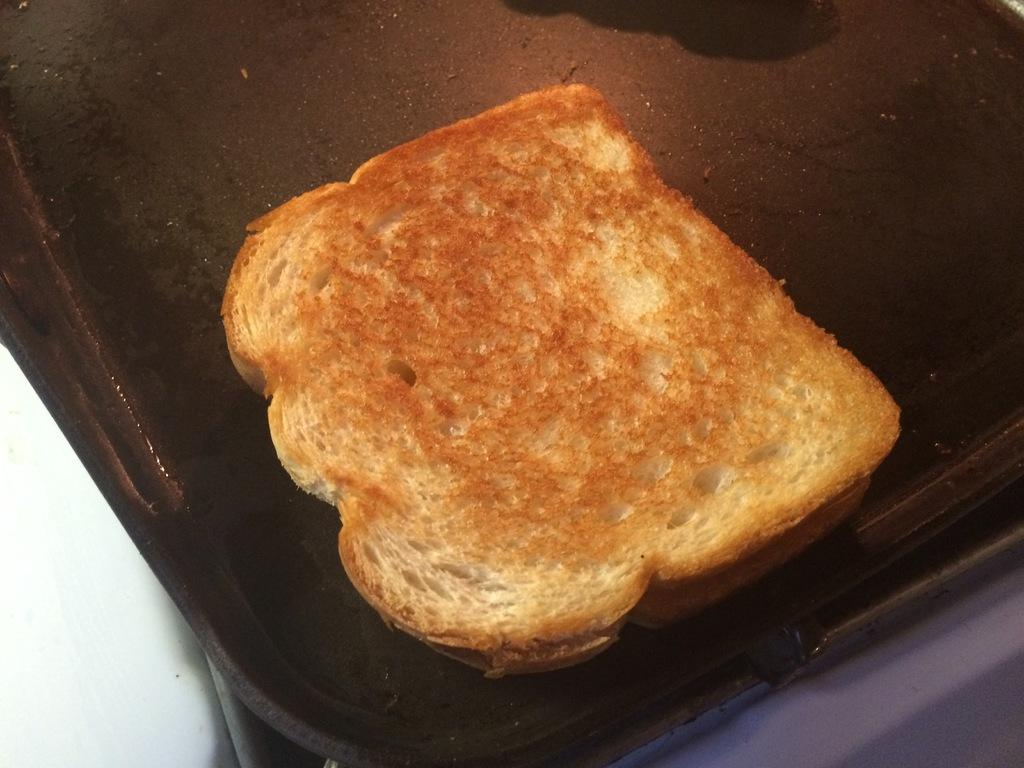What object is present in the image that can hold items? There is a tray in the image that can hold items. What type of food is on the tray? The tray contains bread. Where is the tray located in the image? The tray is on a table. How many cords are connected to the bread on the tray? There are no cords connected to the bread on the tray, as the image only shows a tray with bread on a table. 